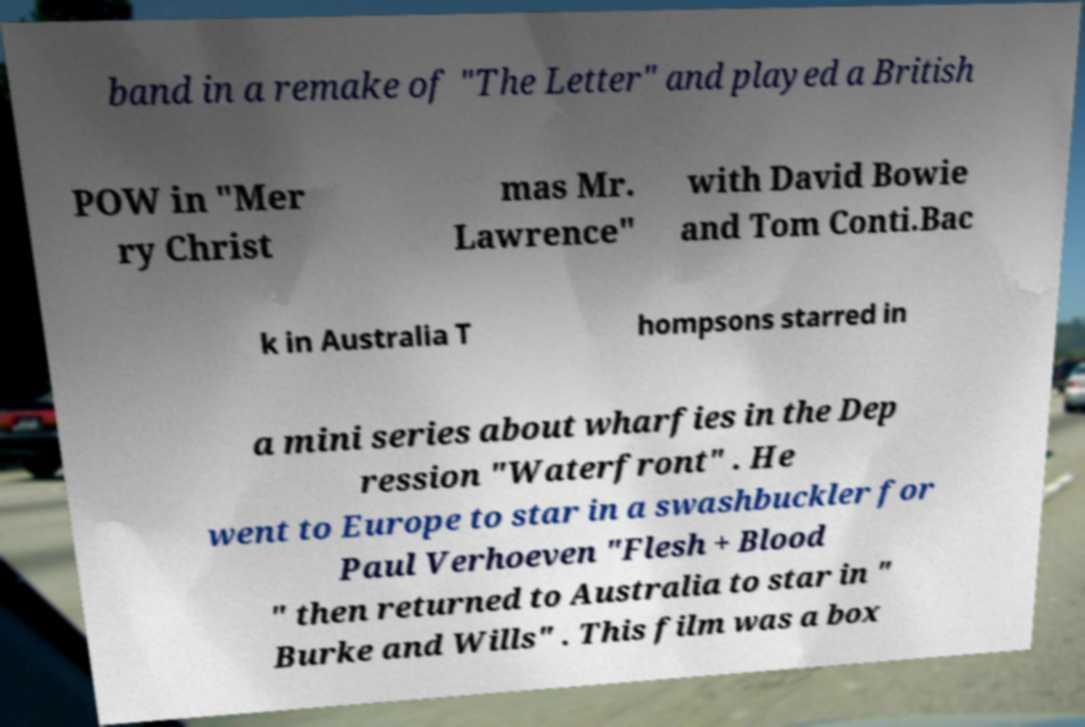Please read and relay the text visible in this image. What does it say? band in a remake of "The Letter" and played a British POW in "Mer ry Christ mas Mr. Lawrence" with David Bowie and Tom Conti.Bac k in Australia T hompsons starred in a mini series about wharfies in the Dep ression "Waterfront" . He went to Europe to star in a swashbuckler for Paul Verhoeven "Flesh + Blood " then returned to Australia to star in " Burke and Wills" . This film was a box 